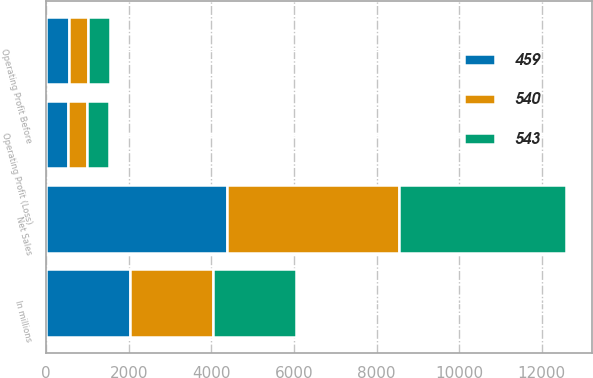Convert chart. <chart><loc_0><loc_0><loc_500><loc_500><stacked_bar_chart><ecel><fcel>In millions<fcel>Net Sales<fcel>Operating Profit (Loss)<fcel>Operating Profit Before<nl><fcel>459<fcel>2018<fcel>4375<fcel>533<fcel>543<nl><fcel>540<fcel>2017<fcel>4157<fcel>457<fcel>459<nl><fcel>543<fcel>2016<fcel>4058<fcel>540<fcel>540<nl></chart> 